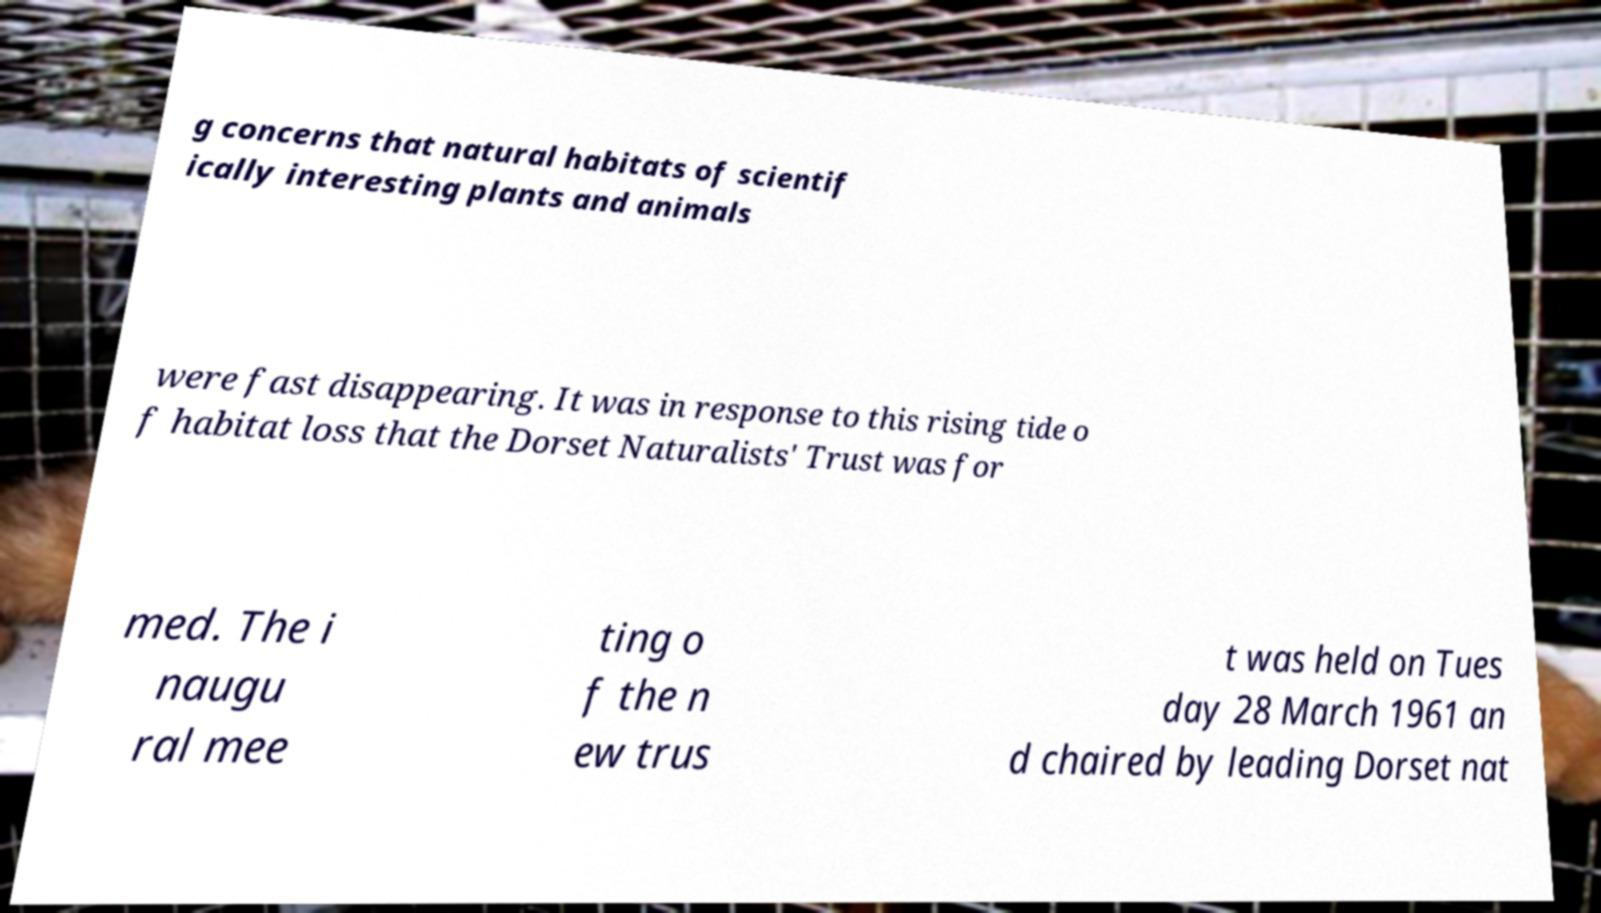Please identify and transcribe the text found in this image. g concerns that natural habitats of scientif ically interesting plants and animals were fast disappearing. It was in response to this rising tide o f habitat loss that the Dorset Naturalists' Trust was for med. The i naugu ral mee ting o f the n ew trus t was held on Tues day 28 March 1961 an d chaired by leading Dorset nat 